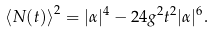<formula> <loc_0><loc_0><loc_500><loc_500>\left \langle N ( t ) \right \rangle ^ { 2 } = | \alpha | ^ { 4 } - 2 4 g ^ { 2 } t ^ { 2 } | \alpha | ^ { 6 } .</formula> 